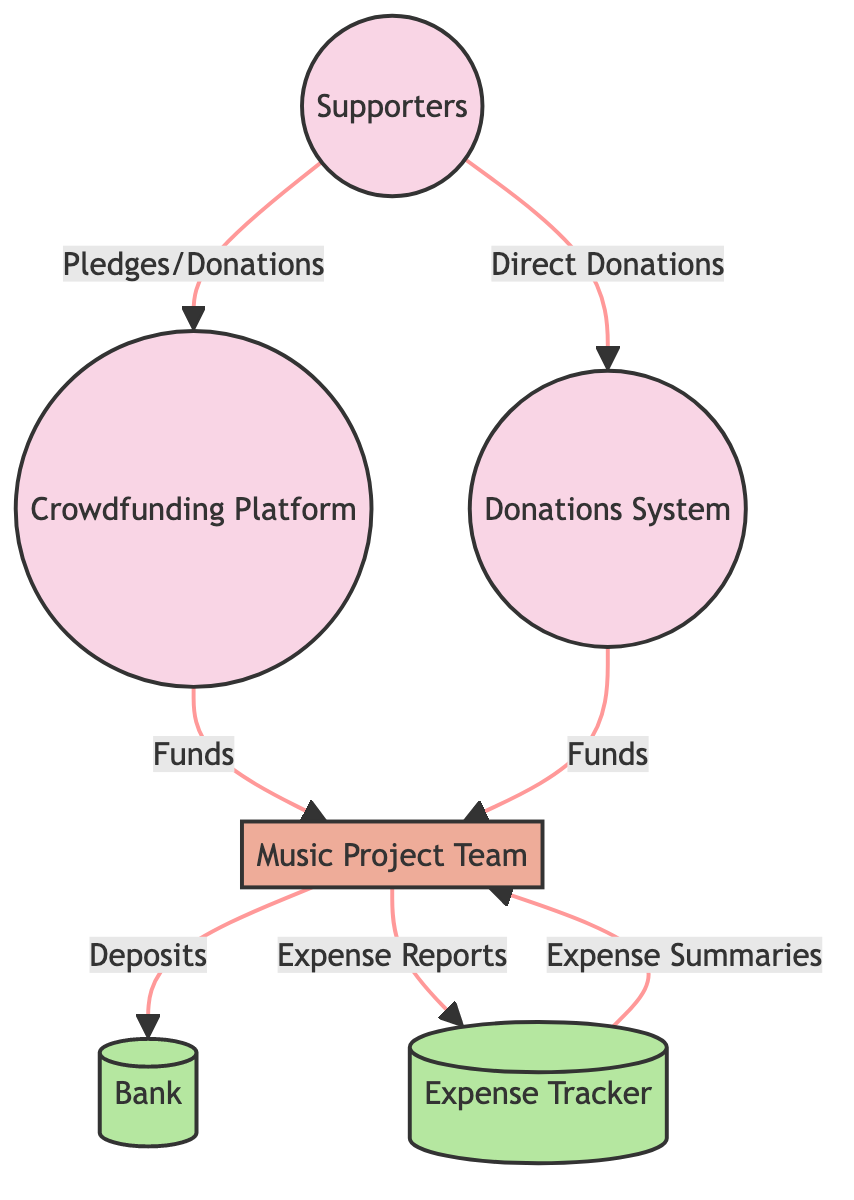What types of external entities are present in the diagram? The diagram includes three external entities: Supporters, Crowdfunding Platform, and Donations System. Each fits the designation of External Entity as categorized.
Answer: Supporters, Crowdfunding Platform, Donations System How many data flows are there in total? By counting each directed arrow between the entities and processes, we identify a total of six distinct data flows connecting the various elements of the diagram.
Answer: Six What does the Music Project Team do with deposits? The Music Project Team deposits funds into the Bank, as indicated by the directed flow from the team to the data store labeled Bank by the data flow noted as "Deposits."
Answer: Deposits Which external entity provides funds through direct donations? The Donations System is responsible for channeling direct donations from supporters to the Music Project Team, evidenced by the data flow labeled "Funds" originating from the Donations System.
Answer: Donations System What primary function does the Expense Tracker serve? The Expense Tracker is a data store that maintains records of all expenses related to the music project, which is explicitly described in the diagram.
Answer: Stores records of expenses What is the process called that manages funds and tracks expenses? In the diagram, the process responsible for managing incoming funds from crowdfunding and direct donations as well as tracking expenses is labeled as Fund Management.
Answer: Fund Management How does the Music Project Team receive funds from the crowdfunding platform? The funds flow from the Crowdfunding Platform directly to the Music Project Team, generating a connection marked clearly in the diagram by the label "Funds" for this flow.
Answer: Funds What type of data store is the Expense Tracker categorized as? The Expense Tracker is categorized as a data store, which is indicated by its specific labeling and description in the diagram.
Answer: Data Store What do supporters supply to both the Crowdfunding Platform and the Donations System? Supporters provide Pledges/Donations to the Crowdfunding Platform and Direct Donations to the Donations System, as shown by the respective data flows in the diagram.
Answer: Pledges/Donations, Direct Donations 